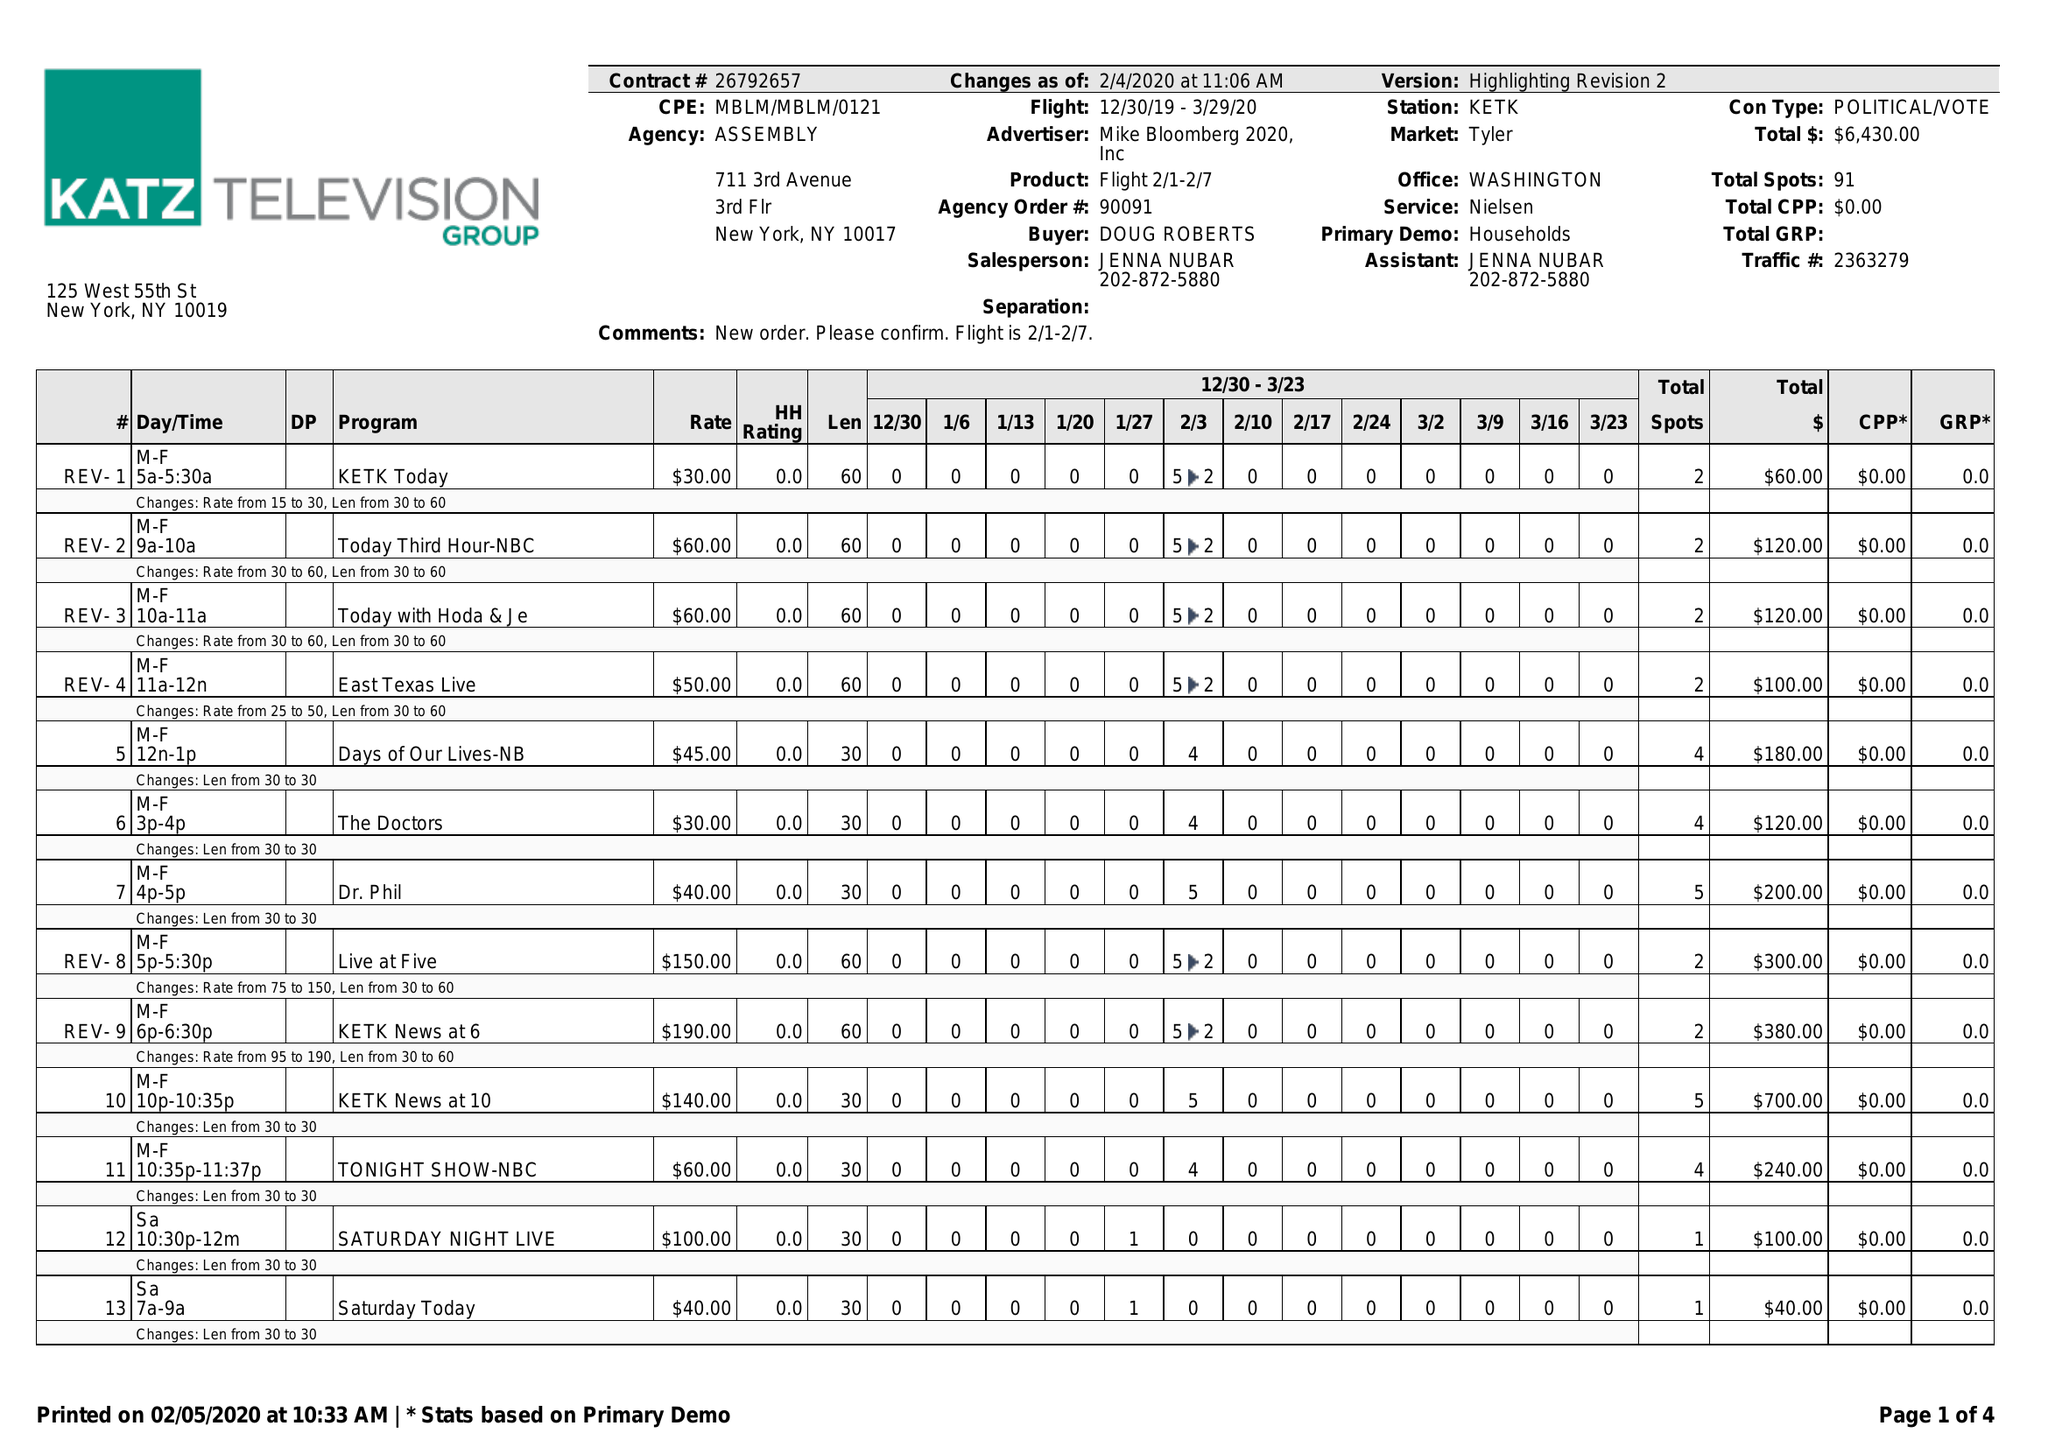What is the value for the flight_to?
Answer the question using a single word or phrase. 03/29/20 